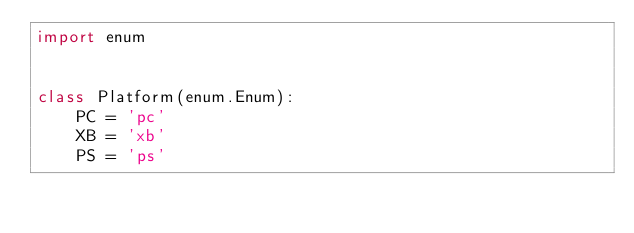Convert code to text. <code><loc_0><loc_0><loc_500><loc_500><_Python_>import enum


class Platform(enum.Enum):
    PC = 'pc'
    XB = 'xb'
    PS = 'ps'
</code> 